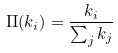<formula> <loc_0><loc_0><loc_500><loc_500>\Pi ( k _ { i } ) = \frac { k _ { i } } { \sum _ { j } k _ { j } }</formula> 